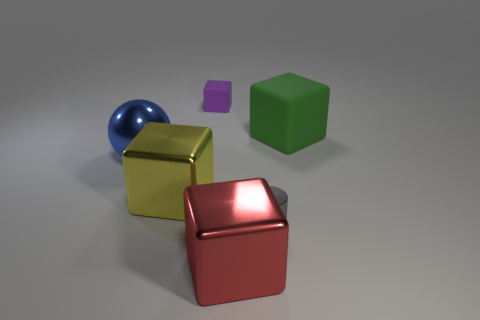Can you think of any real-world applications for these objects? While the objects in the image are likely for illustrative purposes, similar real-world applications could include children's toy blocks for the cubes and a decorative paperweight or geometric reference model for the sphere. 